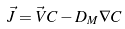Convert formula to latex. <formula><loc_0><loc_0><loc_500><loc_500>\vec { J } = \vec { V } C - D _ { M } \nabla C</formula> 